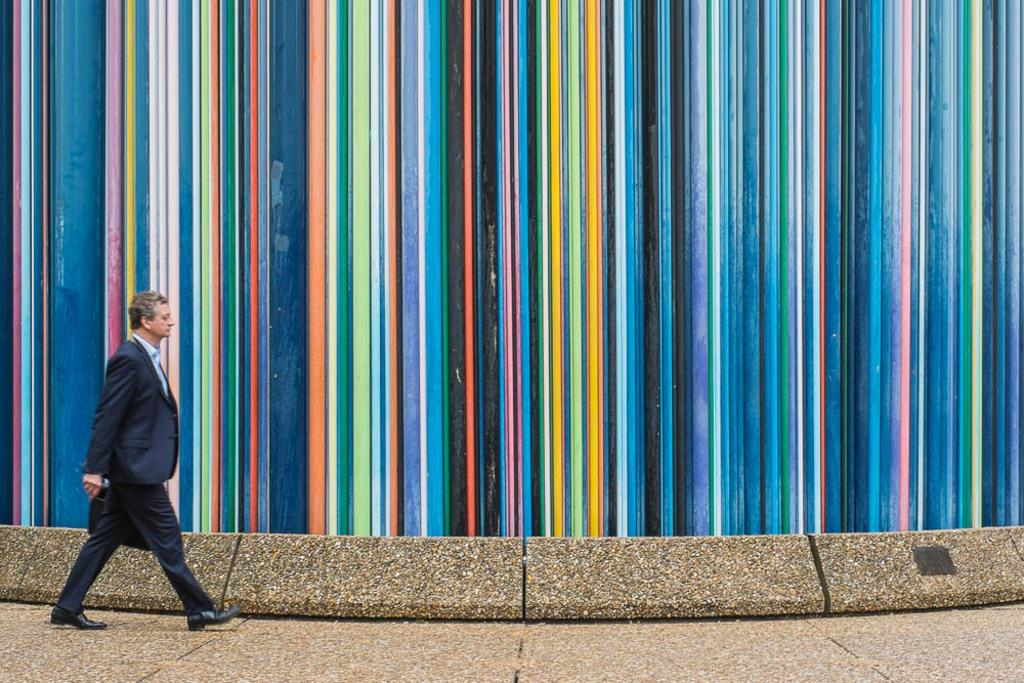What is the main subject of the image? The main subject of the image is a person walking. What is the person carrying in the image? The person is carrying an object in the image. Can you describe the background of the image? There is a multi-colored wall in the image. What type of tools does the carpenter use in the image? There is no carpenter present in the image, nor are there any tools visible. 